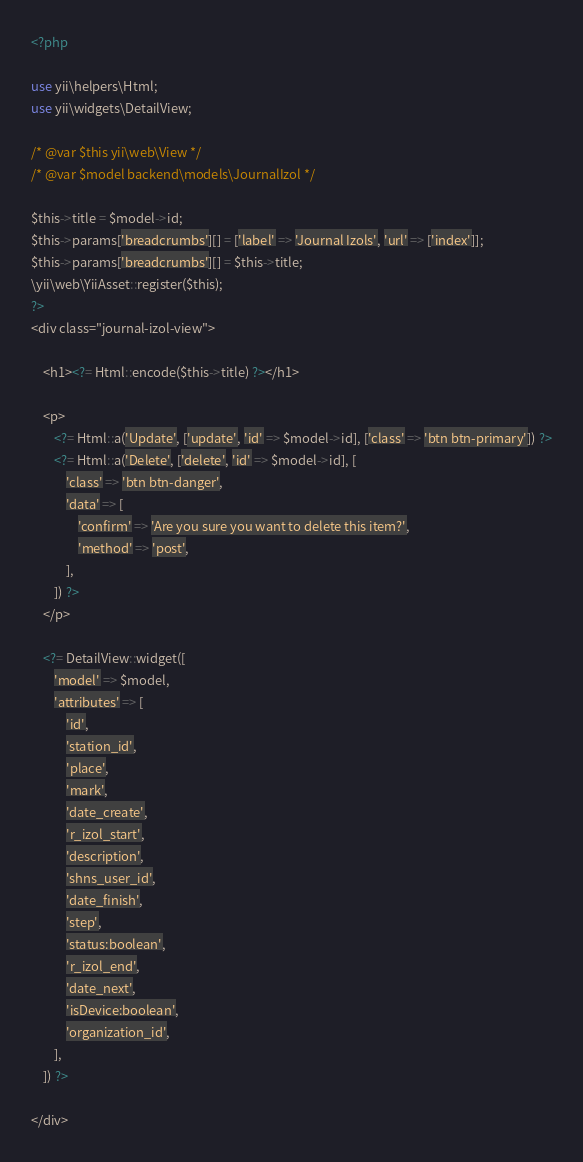<code> <loc_0><loc_0><loc_500><loc_500><_PHP_><?php

use yii\helpers\Html;
use yii\widgets\DetailView;

/* @var $this yii\web\View */
/* @var $model backend\models\JournalIzol */

$this->title = $model->id;
$this->params['breadcrumbs'][] = ['label' => 'Journal Izols', 'url' => ['index']];
$this->params['breadcrumbs'][] = $this->title;
\yii\web\YiiAsset::register($this);
?>
<div class="journal-izol-view">

    <h1><?= Html::encode($this->title) ?></h1>

    <p>
        <?= Html::a('Update', ['update', 'id' => $model->id], ['class' => 'btn btn-primary']) ?>
        <?= Html::a('Delete', ['delete', 'id' => $model->id], [
            'class' => 'btn btn-danger',
            'data' => [
                'confirm' => 'Are you sure you want to delete this item?',
                'method' => 'post',
            ],
        ]) ?>
    </p>

    <?= DetailView::widget([
        'model' => $model,
        'attributes' => [
            'id',
            'station_id',
            'place',
            'mark',
            'date_create',
            'r_izol_start',
            'description',
            'shns_user_id',
            'date_finish',
            'step',
            'status:boolean',
            'r_izol_end',
            'date_next',
            'isDevice:boolean',
            'organization_id',
        ],
    ]) ?>

</div>
</code> 